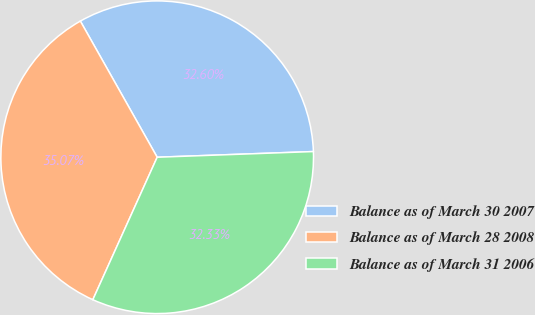Convert chart. <chart><loc_0><loc_0><loc_500><loc_500><pie_chart><fcel>Balance as of March 30 2007<fcel>Balance as of March 28 2008<fcel>Balance as of March 31 2006<nl><fcel>32.6%<fcel>35.07%<fcel>32.33%<nl></chart> 